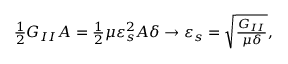<formula> <loc_0><loc_0><loc_500><loc_500>\begin{array} { r } { \frac { 1 } { 2 } G _ { I I } A = \frac { 1 } { 2 } \mu \varepsilon _ { s } ^ { 2 } A \delta \to \varepsilon _ { s } = \sqrt { \frac { G _ { I I } } { \mu \delta } } , } \end{array}</formula> 